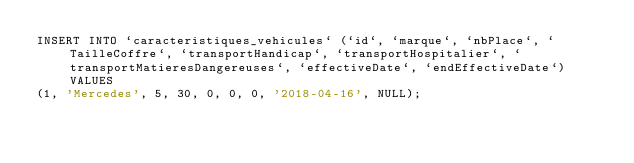Convert code to text. <code><loc_0><loc_0><loc_500><loc_500><_SQL_>INSERT INTO `caracteristiques_vehicules` (`id`, `marque`, `nbPlace`, `TailleCoffre`, `transportHandicap`, `transportHospitalier`, `transportMatieresDangereuses`, `effectiveDate`, `endEffectiveDate`) VALUES
(1, 'Mercedes', 5, 30, 0, 0, 0, '2018-04-16', NULL);</code> 